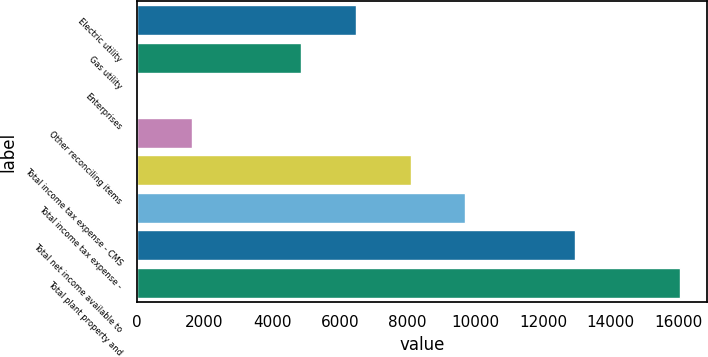Convert chart to OTSL. <chart><loc_0><loc_0><loc_500><loc_500><bar_chart><fcel>Electric utility<fcel>Gas utility<fcel>Enterprises<fcel>Other reconciling items<fcel>Total income tax expense - CMS<fcel>Total income tax expense -<fcel>Total net income available to<fcel>Total plant property and<nl><fcel>6476<fcel>4858<fcel>4<fcel>1622<fcel>8094<fcel>9712<fcel>12948<fcel>16044<nl></chart> 